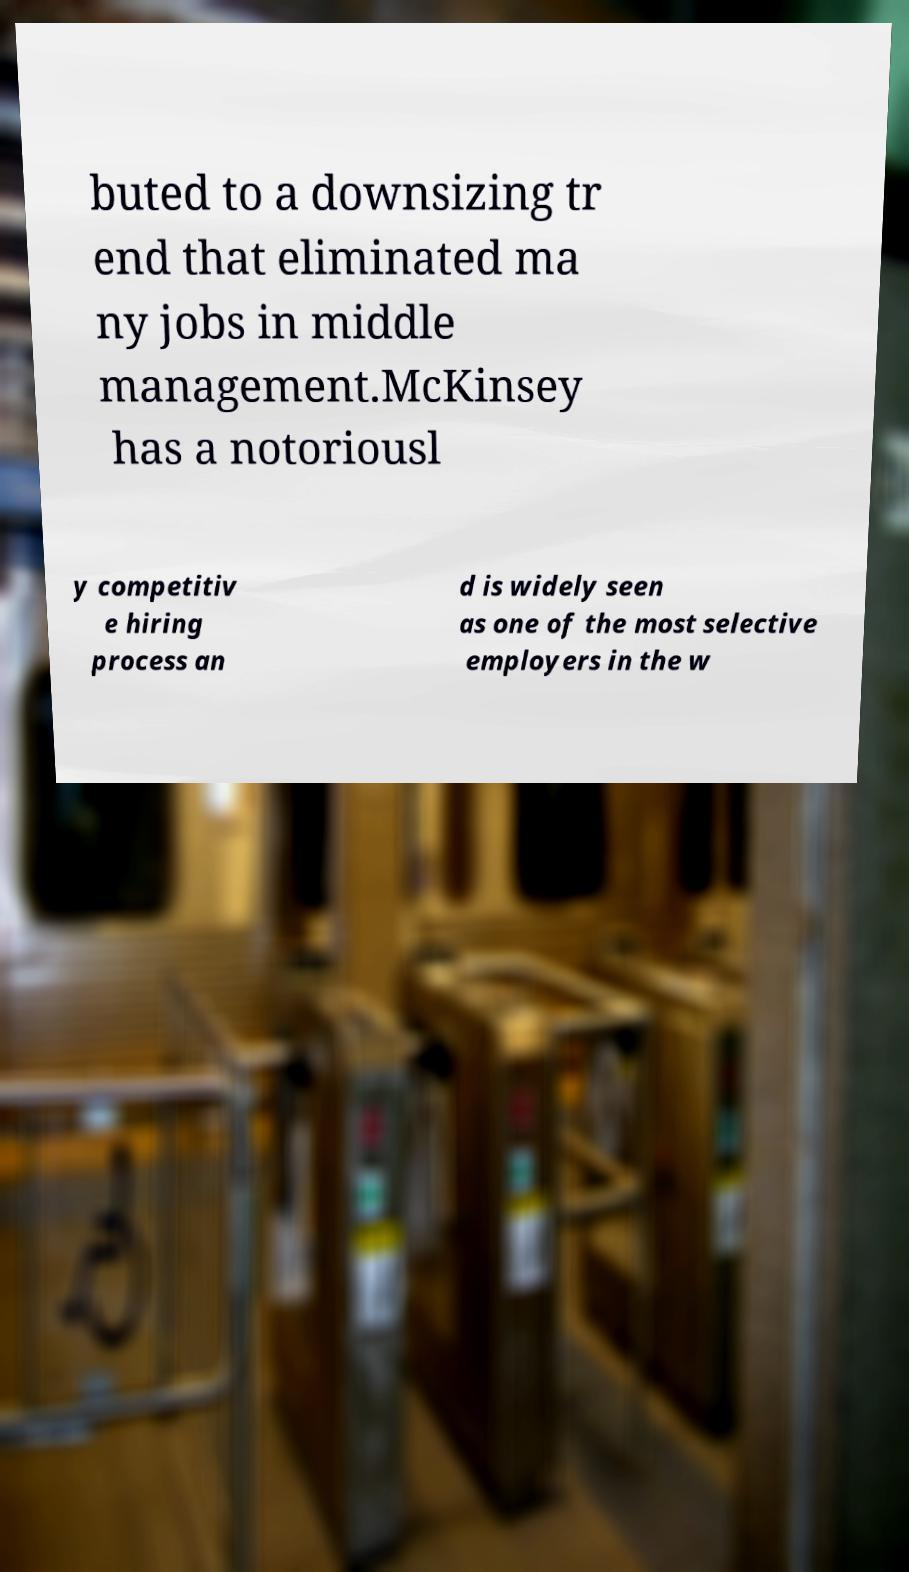Please read and relay the text visible in this image. What does it say? buted to a downsizing tr end that eliminated ma ny jobs in middle management.McKinsey has a notoriousl y competitiv e hiring process an d is widely seen as one of the most selective employers in the w 